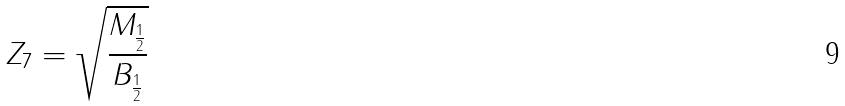<formula> <loc_0><loc_0><loc_500><loc_500>Z _ { 7 } = \sqrt { \frac { M _ { \frac { 1 } { 2 } } } { B _ { \frac { 1 } { 2 } } } }</formula> 